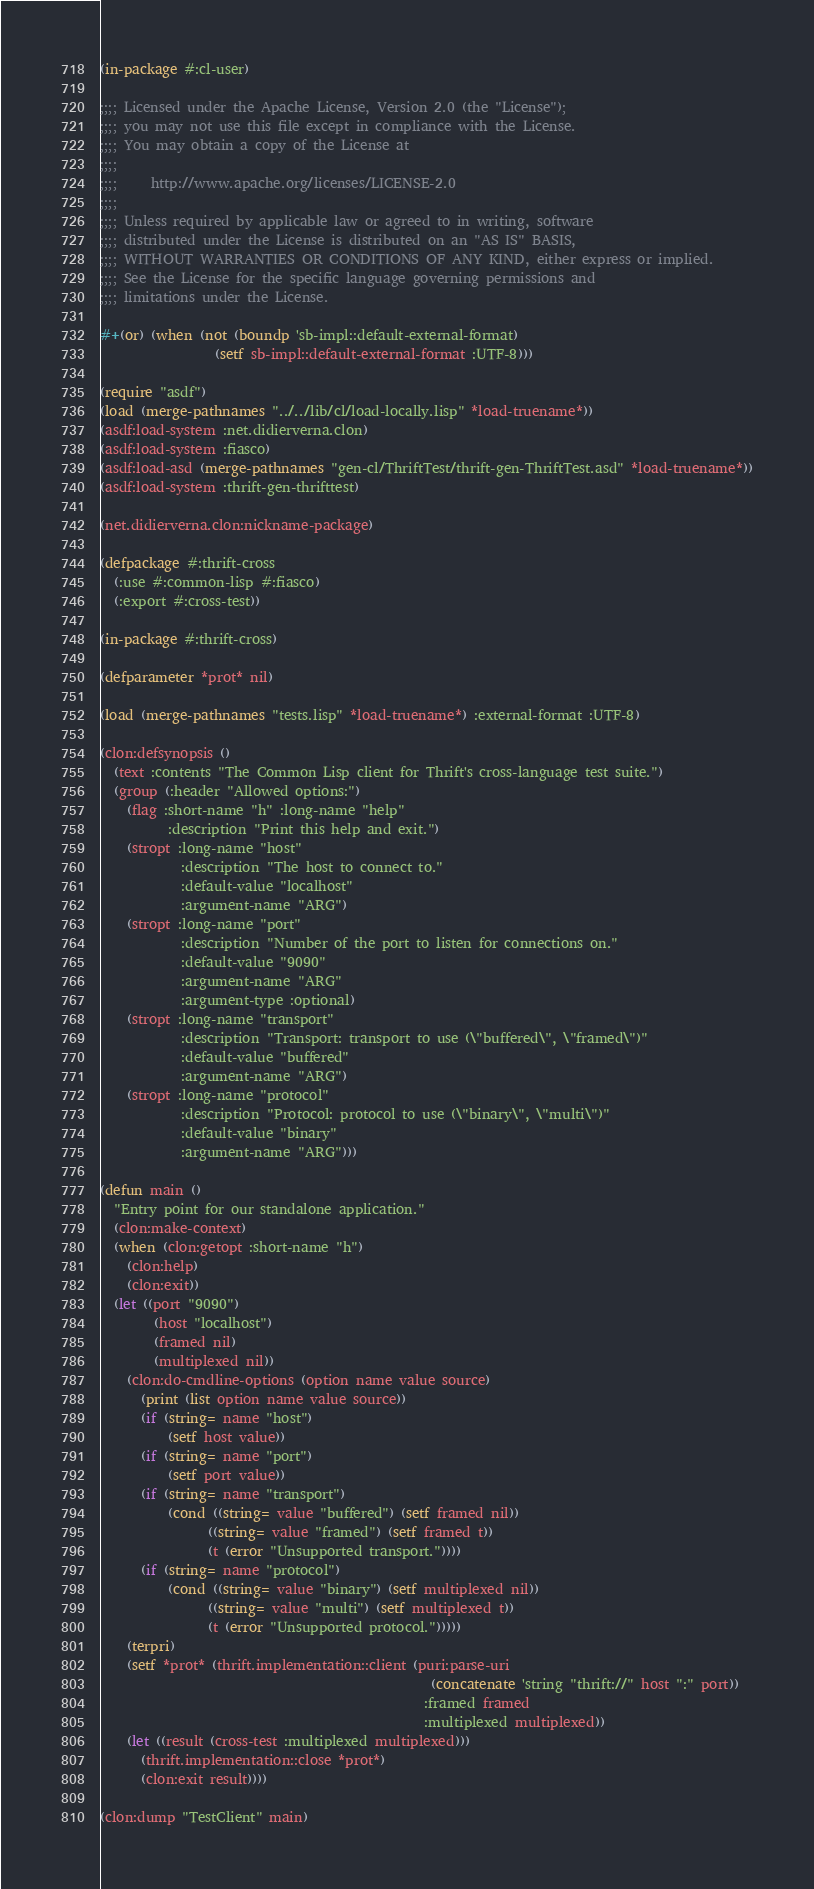Convert code to text. <code><loc_0><loc_0><loc_500><loc_500><_Lisp_>(in-package #:cl-user)

;;;; Licensed under the Apache License, Version 2.0 (the "License");
;;;; you may not use this file except in compliance with the License.
;;;; You may obtain a copy of the License at
;;;;
;;;;     http://www.apache.org/licenses/LICENSE-2.0
;;;;
;;;; Unless required by applicable law or agreed to in writing, software
;;;; distributed under the License is distributed on an "AS IS" BASIS,
;;;; WITHOUT WARRANTIES OR CONDITIONS OF ANY KIND, either express or implied.
;;;; See the License for the specific language governing permissions and
;;;; limitations under the License.

#+(or) (when (not (boundp 'sb-impl::default-external-format)
                 (setf sb-impl::default-external-format :UTF-8)))

(require "asdf")
(load (merge-pathnames "../../lib/cl/load-locally.lisp" *load-truename*))
(asdf:load-system :net.didierverna.clon)
(asdf:load-system :fiasco)
(asdf:load-asd (merge-pathnames "gen-cl/ThriftTest/thrift-gen-ThriftTest.asd" *load-truename*))
(asdf:load-system :thrift-gen-thrifttest)

(net.didierverna.clon:nickname-package)

(defpackage #:thrift-cross
  (:use #:common-lisp #:fiasco)
  (:export #:cross-test))

(in-package #:thrift-cross)

(defparameter *prot* nil)

(load (merge-pathnames "tests.lisp" *load-truename*) :external-format :UTF-8)

(clon:defsynopsis ()
  (text :contents "The Common Lisp client for Thrift's cross-language test suite.")
  (group (:header "Allowed options:")
    (flag :short-name "h" :long-name "help"
          :description "Print this help and exit.")
    (stropt :long-name "host"
            :description "The host to connect to."
            :default-value "localhost"
            :argument-name "ARG")
    (stropt :long-name "port"
            :description "Number of the port to listen for connections on."
            :default-value "9090"
            :argument-name "ARG"
            :argument-type :optional)
    (stropt :long-name "transport"
            :description "Transport: transport to use (\"buffered\", \"framed\")"
            :default-value "buffered"
            :argument-name "ARG")
    (stropt :long-name "protocol"
            :description "Protocol: protocol to use (\"binary\", \"multi\")"
            :default-value "binary"
            :argument-name "ARG")))

(defun main ()
  "Entry point for our standalone application."
  (clon:make-context)
  (when (clon:getopt :short-name "h")
    (clon:help)
    (clon:exit))
  (let ((port "9090")
        (host "localhost")
        (framed nil)
        (multiplexed nil))
    (clon:do-cmdline-options (option name value source)
      (print (list option name value source))
      (if (string= name "host")
          (setf host value))
      (if (string= name "port")
          (setf port value))
      (if (string= name "transport")
          (cond ((string= value "buffered") (setf framed nil))
                ((string= value "framed") (setf framed t))
                (t (error "Unsupported transport."))))
      (if (string= name "protocol")
          (cond ((string= value "binary") (setf multiplexed nil))
                ((string= value "multi") (setf multiplexed t))
                (t (error "Unsupported protocol.")))))
    (terpri)
    (setf *prot* (thrift.implementation::client (puri:parse-uri
                                                 (concatenate 'string "thrift://" host ":" port))
                                                :framed framed
                                                :multiplexed multiplexed))
    (let ((result (cross-test :multiplexed multiplexed)))
      (thrift.implementation::close *prot*)
      (clon:exit result))))

(clon:dump "TestClient" main)
</code> 